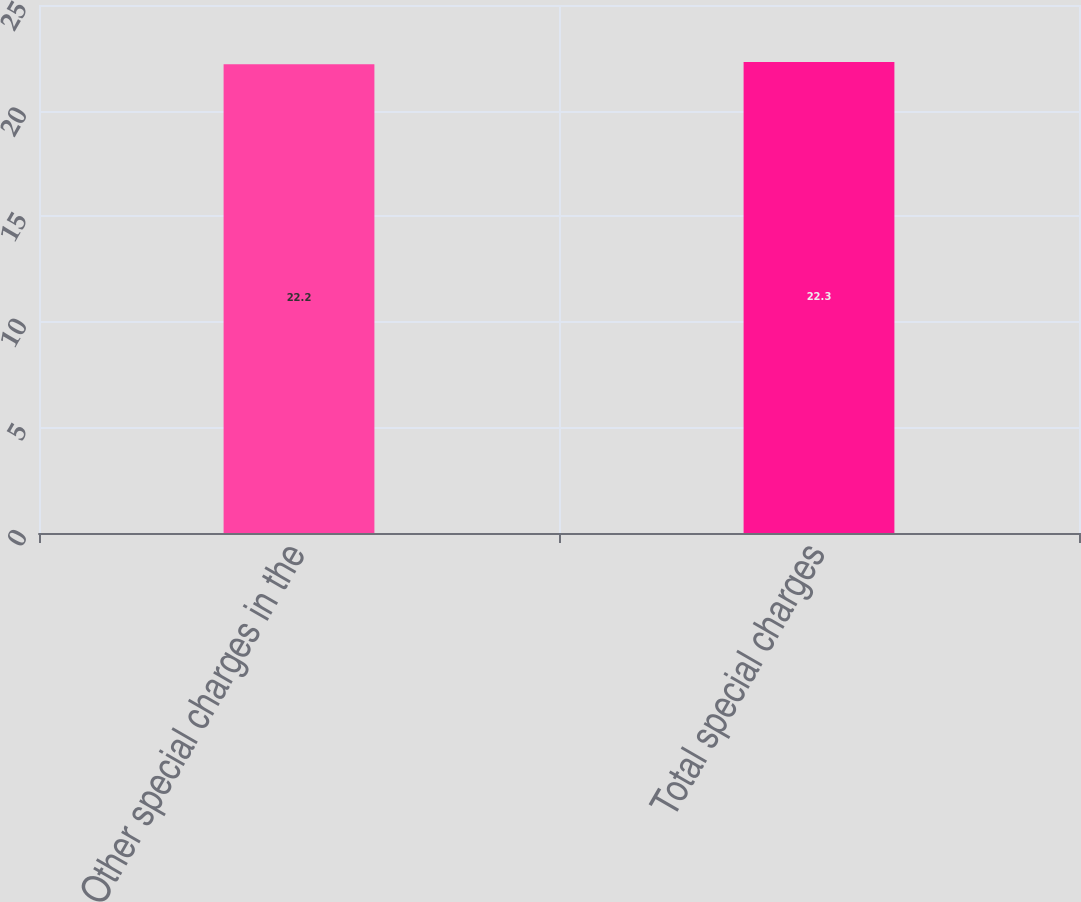Convert chart to OTSL. <chart><loc_0><loc_0><loc_500><loc_500><bar_chart><fcel>Other special charges in the<fcel>Total special charges<nl><fcel>22.2<fcel>22.3<nl></chart> 